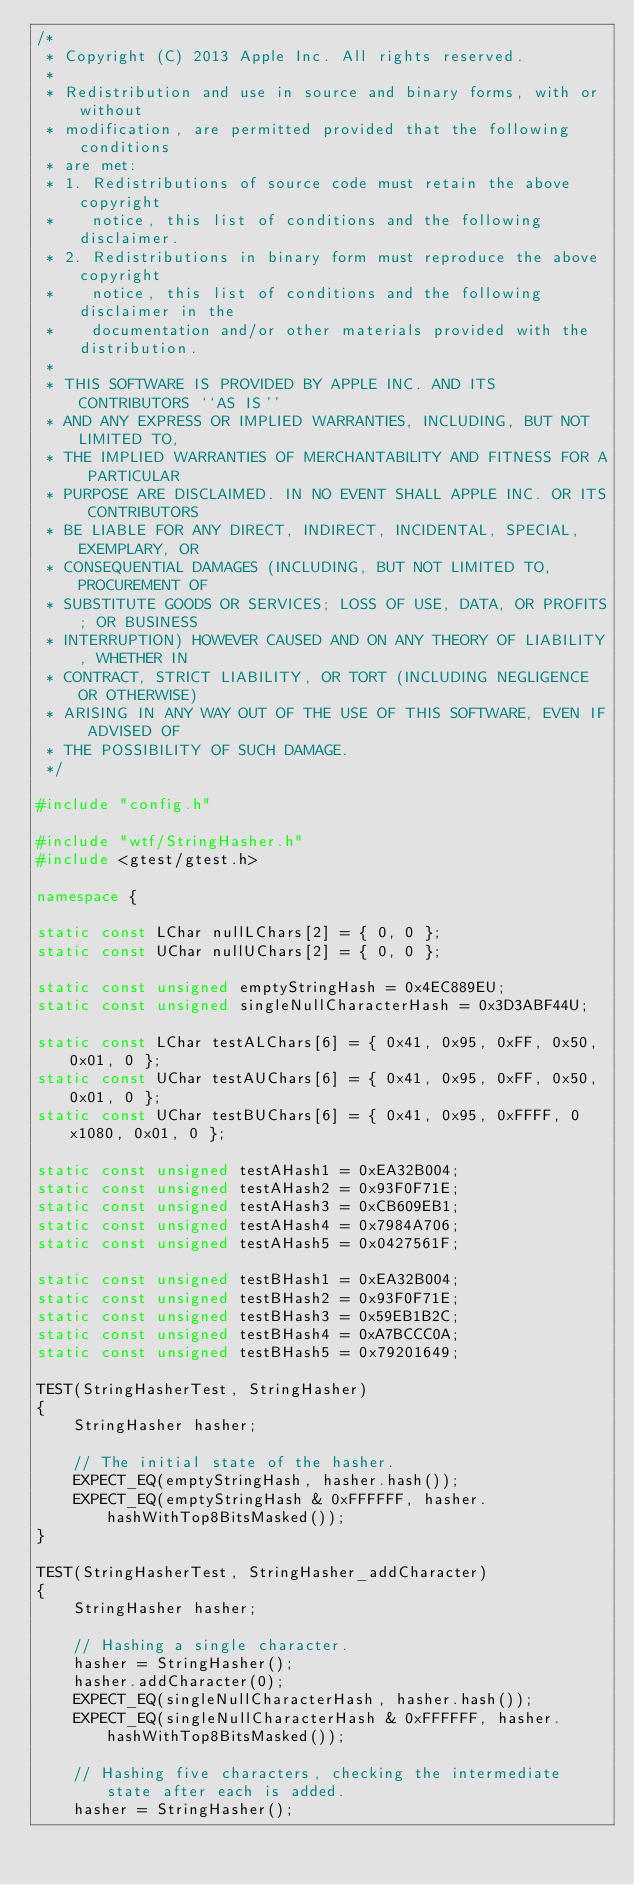Convert code to text. <code><loc_0><loc_0><loc_500><loc_500><_C++_>/*
 * Copyright (C) 2013 Apple Inc. All rights reserved.
 *
 * Redistribution and use in source and binary forms, with or without
 * modification, are permitted provided that the following conditions
 * are met:
 * 1. Redistributions of source code must retain the above copyright
 *    notice, this list of conditions and the following disclaimer.
 * 2. Redistributions in binary form must reproduce the above copyright
 *    notice, this list of conditions and the following disclaimer in the
 *    documentation and/or other materials provided with the distribution.
 *
 * THIS SOFTWARE IS PROVIDED BY APPLE INC. AND ITS CONTRIBUTORS ``AS IS''
 * AND ANY EXPRESS OR IMPLIED WARRANTIES, INCLUDING, BUT NOT LIMITED TO,
 * THE IMPLIED WARRANTIES OF MERCHANTABILITY AND FITNESS FOR A PARTICULAR
 * PURPOSE ARE DISCLAIMED. IN NO EVENT SHALL APPLE INC. OR ITS CONTRIBUTORS
 * BE LIABLE FOR ANY DIRECT, INDIRECT, INCIDENTAL, SPECIAL, EXEMPLARY, OR
 * CONSEQUENTIAL DAMAGES (INCLUDING, BUT NOT LIMITED TO, PROCUREMENT OF
 * SUBSTITUTE GOODS OR SERVICES; LOSS OF USE, DATA, OR PROFITS; OR BUSINESS
 * INTERRUPTION) HOWEVER CAUSED AND ON ANY THEORY OF LIABILITY, WHETHER IN
 * CONTRACT, STRICT LIABILITY, OR TORT (INCLUDING NEGLIGENCE OR OTHERWISE)
 * ARISING IN ANY WAY OUT OF THE USE OF THIS SOFTWARE, EVEN IF ADVISED OF
 * THE POSSIBILITY OF SUCH DAMAGE.
 */

#include "config.h"

#include "wtf/StringHasher.h"
#include <gtest/gtest.h>

namespace {

static const LChar nullLChars[2] = { 0, 0 };
static const UChar nullUChars[2] = { 0, 0 };

static const unsigned emptyStringHash = 0x4EC889EU;
static const unsigned singleNullCharacterHash = 0x3D3ABF44U;

static const LChar testALChars[6] = { 0x41, 0x95, 0xFF, 0x50, 0x01, 0 };
static const UChar testAUChars[6] = { 0x41, 0x95, 0xFF, 0x50, 0x01, 0 };
static const UChar testBUChars[6] = { 0x41, 0x95, 0xFFFF, 0x1080, 0x01, 0 };

static const unsigned testAHash1 = 0xEA32B004;
static const unsigned testAHash2 = 0x93F0F71E;
static const unsigned testAHash3 = 0xCB609EB1;
static const unsigned testAHash4 = 0x7984A706;
static const unsigned testAHash5 = 0x0427561F;

static const unsigned testBHash1 = 0xEA32B004;
static const unsigned testBHash2 = 0x93F0F71E;
static const unsigned testBHash3 = 0x59EB1B2C;
static const unsigned testBHash4 = 0xA7BCCC0A;
static const unsigned testBHash5 = 0x79201649;

TEST(StringHasherTest, StringHasher)
{
    StringHasher hasher;

    // The initial state of the hasher.
    EXPECT_EQ(emptyStringHash, hasher.hash());
    EXPECT_EQ(emptyStringHash & 0xFFFFFF, hasher.hashWithTop8BitsMasked());
}

TEST(StringHasherTest, StringHasher_addCharacter)
{
    StringHasher hasher;

    // Hashing a single character.
    hasher = StringHasher();
    hasher.addCharacter(0);
    EXPECT_EQ(singleNullCharacterHash, hasher.hash());
    EXPECT_EQ(singleNullCharacterHash & 0xFFFFFF, hasher.hashWithTop8BitsMasked());

    // Hashing five characters, checking the intermediate state after each is added.
    hasher = StringHasher();</code> 